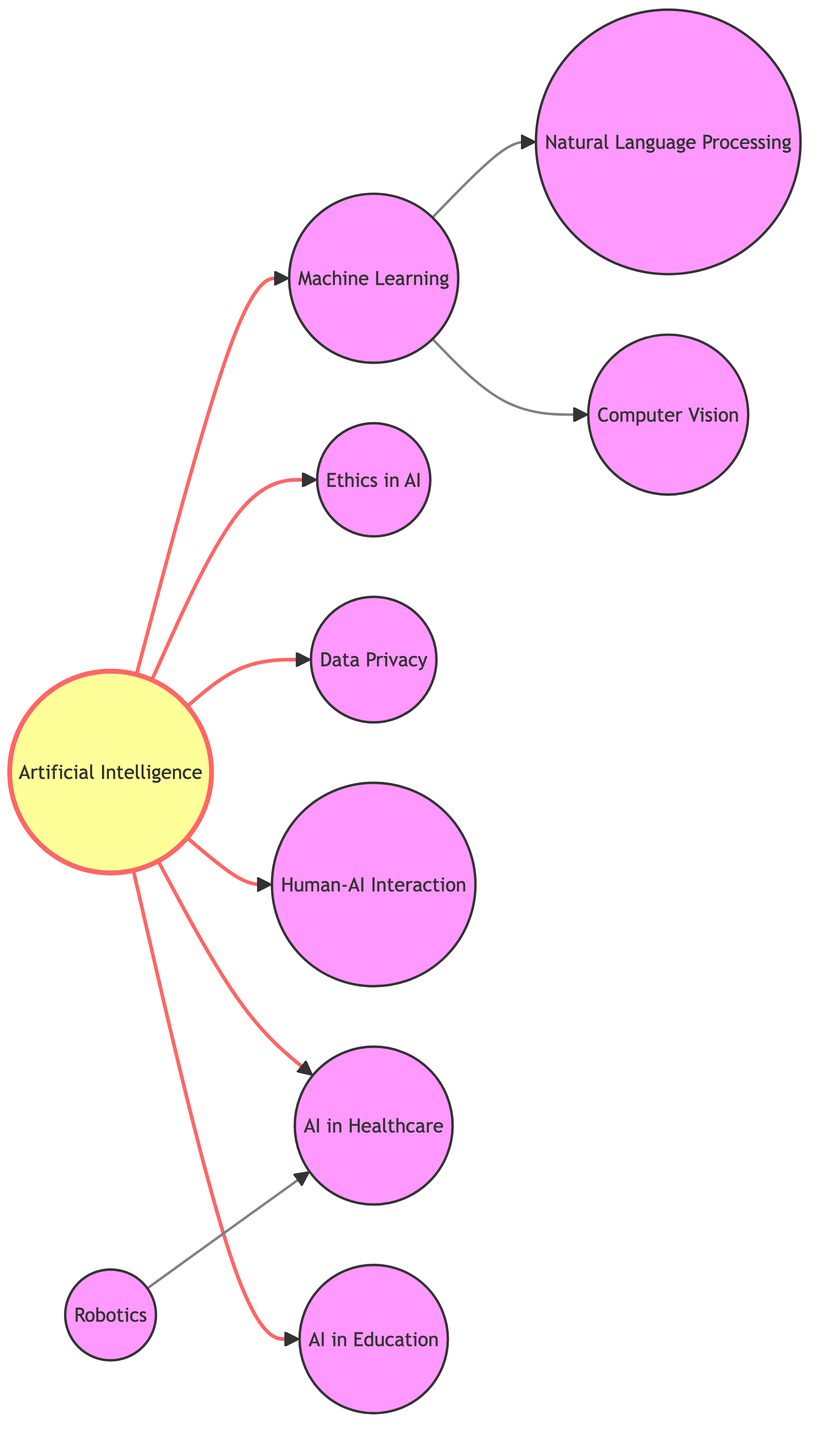What is the total number of nodes in the diagram? The diagram lists nine unique topics related to the conference, which are represented as nodes. Counting them provides the total number.
Answer: 10 Which topic is directly connected to "Machine Learning"? "Machine Learning" has direct connections to "Natural Language Processing" and "Computer Vision." By examining its outgoing edges, these are the two subtopics it connects to.
Answer: Natural Language Processing and Computer Vision What are the two ethical concerns highlighted in relation to "Artificial Intelligence"? The "Artificial Intelligence" node has direct connections to "Ethics in AI" and "Data Privacy." This indicates that these are two critical ethical discussions stemming from AI.
Answer: Ethics in AI and Data Privacy Which node represents the application of AI in education? In the diagram, there is a node labeled "AI in Education," which is directly connected to the central node, "Artificial Intelligence." This identifies its importance as an educational application.
Answer: AI in Education How many edges are connected to the "Artificial Intelligence" node? Examining the outgoing edges from the "Artificial Intelligence" node reveals that it connects to multiple topics, providing a total count of edges. The connections are counted to answer this.
Answer: 7 Which specific area connects "Robotics" to "AI in Healthcare"? The diagram shows that "Robotics" has a direct connection to "AI in Healthcare." This linkage suggests that there are discussions around how robotics applies within healthcare settings involving AI.
Answer: AI in Healthcare What is the main topic, or root node, in this diagram? The root node represents the primary topic around which other subtopics cluster. In this diagram, "Artificial Intelligence" serves as that central focus.
Answer: Artificial Intelligence How many subtopics stem directly from "Artificial Intelligence"? By tallying the connections originating from "Artificial Intelligence," we determine the number of direct subtopics related to it in the diagram.
Answer: 7 Which subtopic is the last in the connection from "Machine Learning"? Starting from "Machine Learning," the last node in its direct pathway is "Computer Vision." This is identifiable through the directed edge leading from "Machine Learning."
Answer: Computer Vision Which node has the fewest connections in the diagram? Evaluating all nodes' degrees reveals that "Robotics" has a single outgoing edge to "AI in Healthcare," indicating it has the fewest connections.
Answer: Robotics 